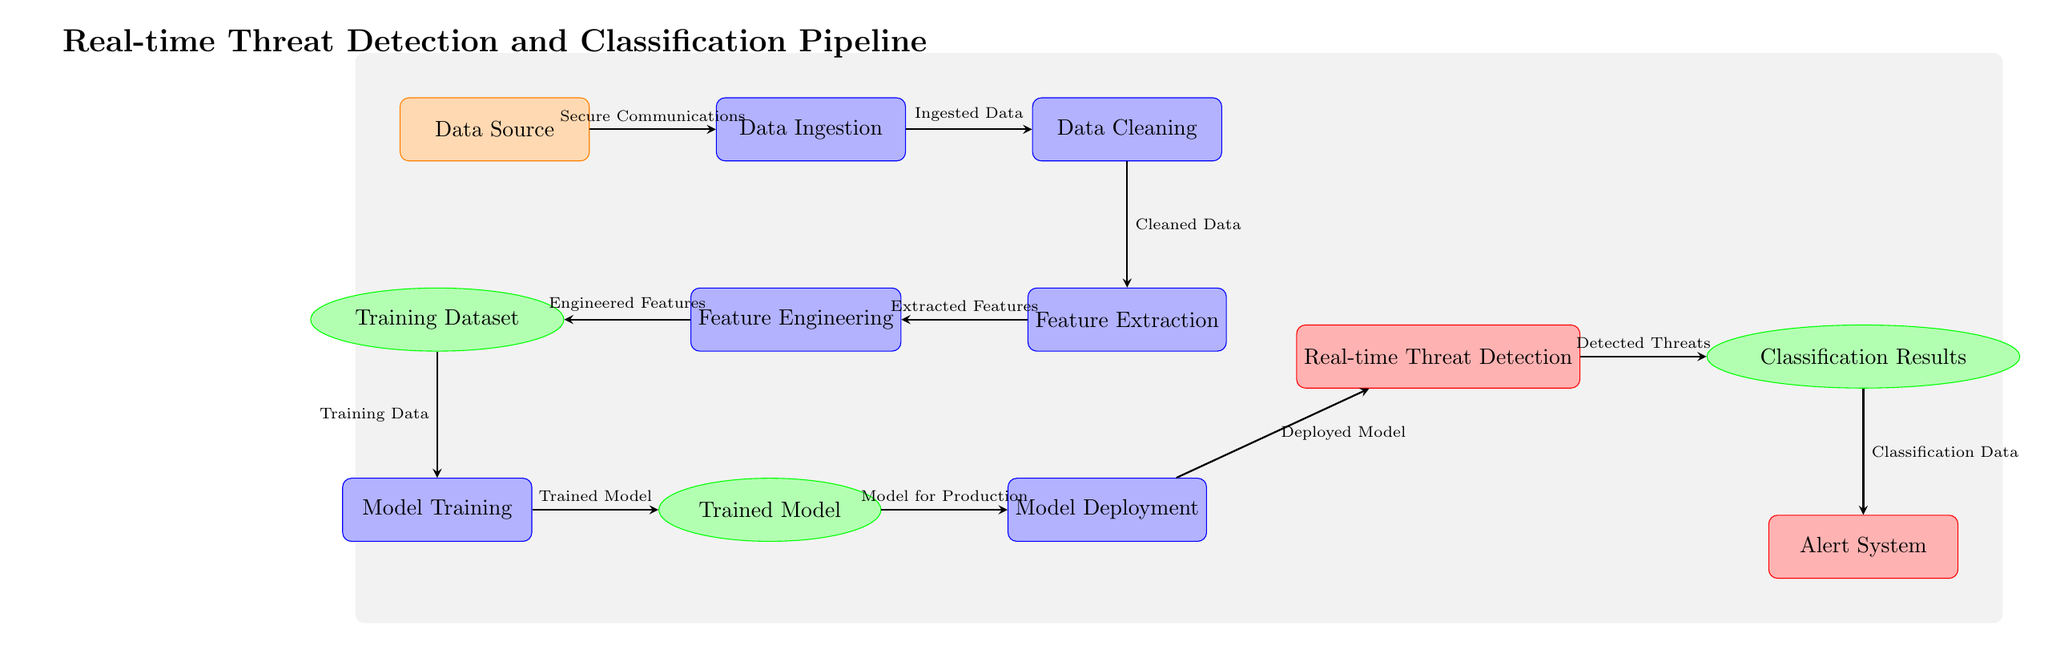What is the first step in the pipeline? The first node in the pipeline is labeled "Data Source," indicating it is the starting point for collecting data.
Answer: Data Source How many processes are involved in the pipeline? The diagram displays six nodes categorized as processes, which include Data Ingestion, Data Cleaning, Feature Extraction, Feature Engineering, Model Training, and Model Deployment.
Answer: Six What type of data is produced by the Feature Extraction process? The arrow leading from Feature Extraction to Feature Engineering is labeled "Extracted Features," which indicates this is the type of data produced at this stage.
Answer: Extracted Features What follows Model Training in the pipeline? After the Model Training node, the diagram shows that the next node is the Trained Model, indicating this is the output of the training phase.
Answer: Trained Model What is the final output of the pipeline? The last arrow from the Classification node to the Alert System indicates that the output being reported is the results sent to the alerting mechanism.
Answer: Alert System Which node provides the model for production? The arrow from the Trained Model node to the Model Deployment node indicates that the trained model serves as the model for deployment in the next step.
Answer: Model for Production What type of features are created after Feature Engineering? The flow from Feature Engineering to Training Dataset indicates that the output at this stage is labeled as "Training Data," representing the processed features for training.
Answer: Training Data How is threat information classified in the pipeline? After Real-time Threat Detection, the arrow leads to the Classification node, suggesting that detected threats are classified through this specific output process.
Answer: Classification Data What do we ingest according to the diagram? The Data Ingestion node indicates that the input collected from the Data Source is referred to as "Ingested Data," reflecting what is processed at this stage.
Answer: Ingested Data 